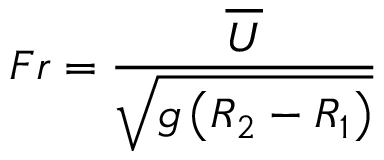Convert formula to latex. <formula><loc_0><loc_0><loc_500><loc_500>F r = \frac { \overline { U } } { \sqrt { g \left ( R _ { 2 } - R _ { 1 } \right ) } }</formula> 